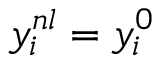<formula> <loc_0><loc_0><loc_500><loc_500>y _ { i } ^ { n l } = y _ { i } ^ { 0 }</formula> 